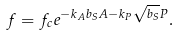Convert formula to latex. <formula><loc_0><loc_0><loc_500><loc_500>f = f _ { c } e ^ { - k _ { A } b _ { S } A - k _ { P } \sqrt { b _ { S } } P } .</formula> 